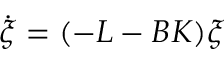<formula> <loc_0><loc_0><loc_500><loc_500>\dot { \xi } = ( - L - B K ) \xi</formula> 